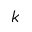<formula> <loc_0><loc_0><loc_500><loc_500>k</formula> 